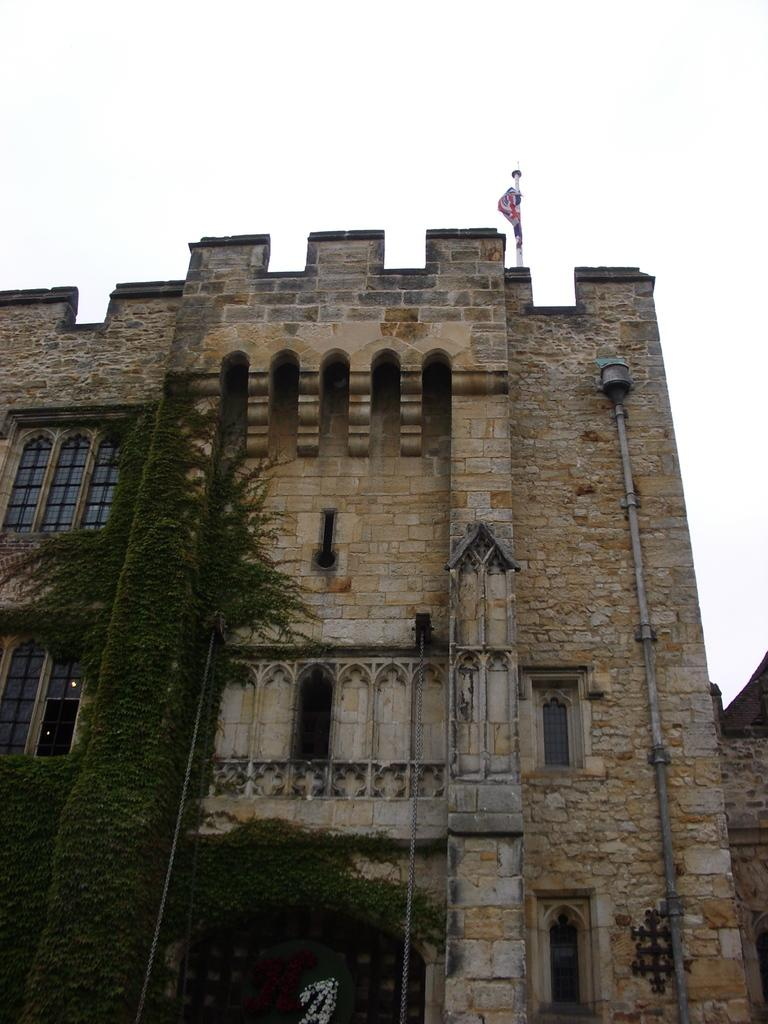What is the main structure in the image? There is a building in the image. What is located above the building? There is a flag above the building. What type of vegetation can be seen on the walls in the image? There is greenery on the walls in the left corner of the image. What time of day is it in the image, and is there any quicksand present? The time of day cannot be determined from the image, and there is no quicksand present. What is the value of the building in the image? The value of the building cannot be determined from the image. 